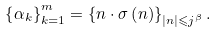Convert formula to latex. <formula><loc_0><loc_0><loc_500><loc_500>\left \{ \alpha _ { k } \right \} _ { k = 1 } ^ { m } = \left \{ n \cdot \sigma \left ( n \right ) \right \} _ { \left | n \right | \leqslant j ^ { \beta } } .</formula> 